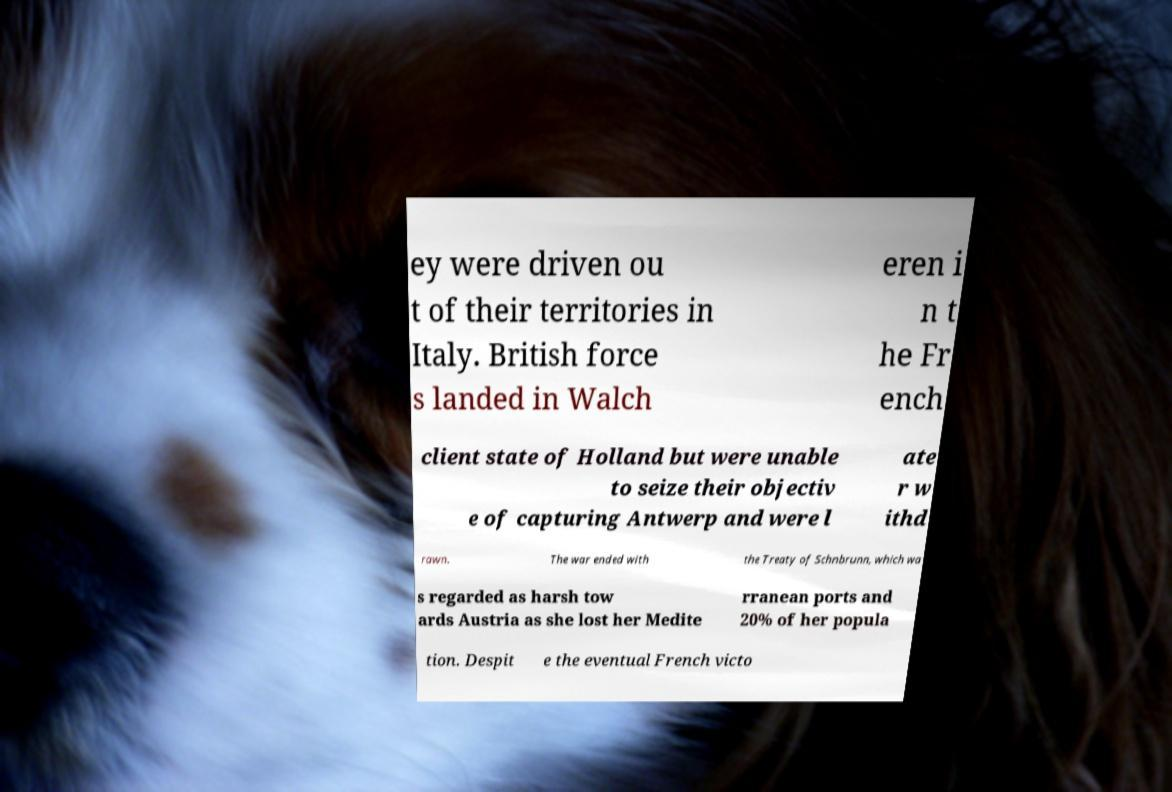Could you assist in decoding the text presented in this image and type it out clearly? ey were driven ou t of their territories in Italy. British force s landed in Walch eren i n t he Fr ench client state of Holland but were unable to seize their objectiv e of capturing Antwerp and were l ate r w ithd rawn. The war ended with the Treaty of Schnbrunn, which wa s regarded as harsh tow ards Austria as she lost her Medite rranean ports and 20% of her popula tion. Despit e the eventual French victo 